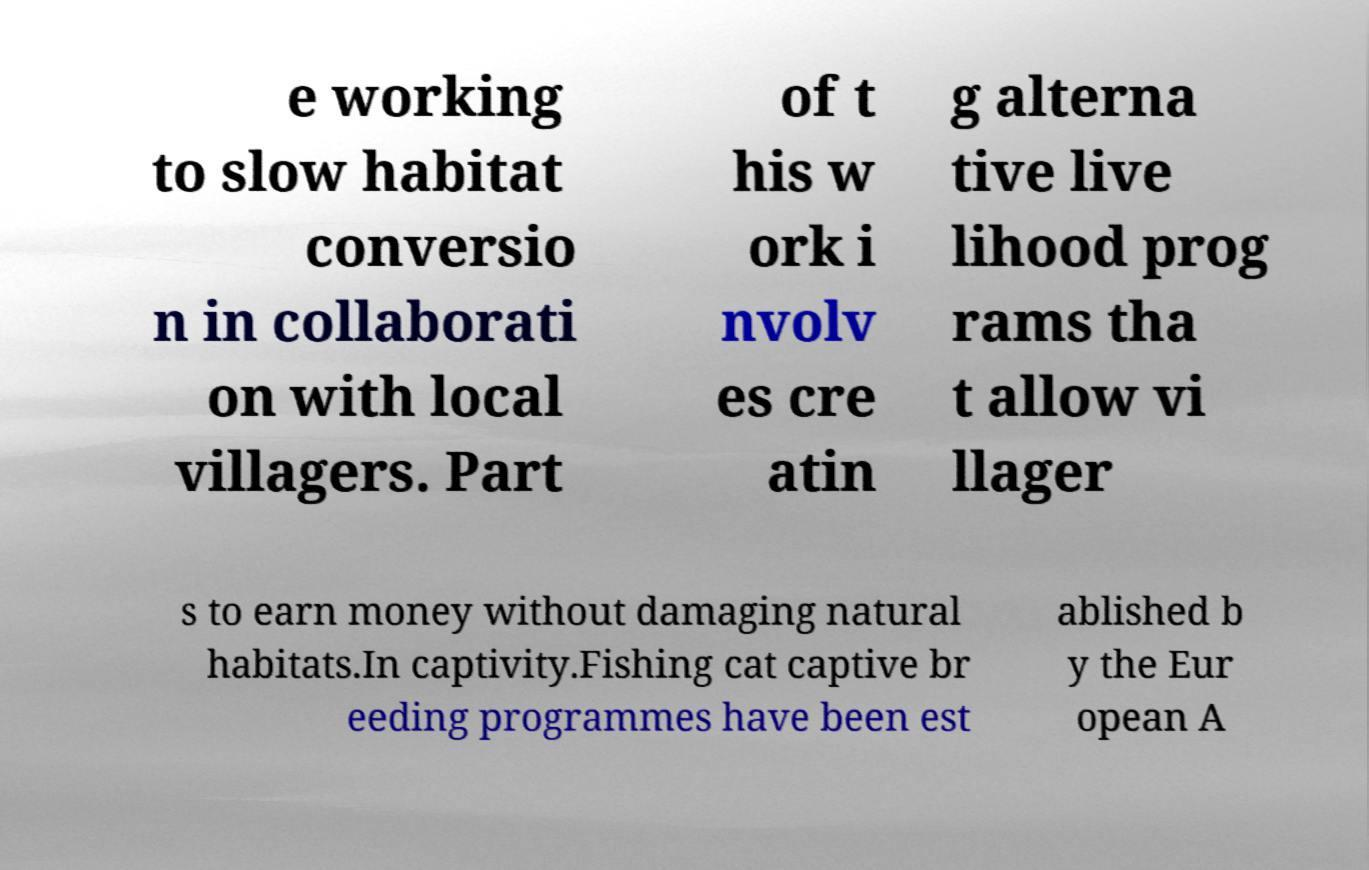For documentation purposes, I need the text within this image transcribed. Could you provide that? e working to slow habitat conversio n in collaborati on with local villagers. Part of t his w ork i nvolv es cre atin g alterna tive live lihood prog rams tha t allow vi llager s to earn money without damaging natural habitats.In captivity.Fishing cat captive br eeding programmes have been est ablished b y the Eur opean A 